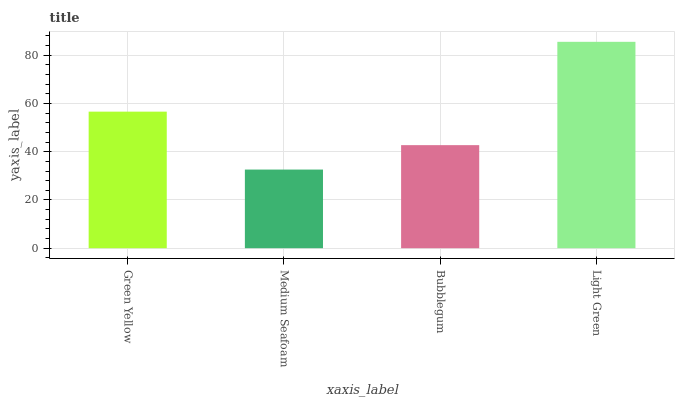Is Medium Seafoam the minimum?
Answer yes or no. Yes. Is Light Green the maximum?
Answer yes or no. Yes. Is Bubblegum the minimum?
Answer yes or no. No. Is Bubblegum the maximum?
Answer yes or no. No. Is Bubblegum greater than Medium Seafoam?
Answer yes or no. Yes. Is Medium Seafoam less than Bubblegum?
Answer yes or no. Yes. Is Medium Seafoam greater than Bubblegum?
Answer yes or no. No. Is Bubblegum less than Medium Seafoam?
Answer yes or no. No. Is Green Yellow the high median?
Answer yes or no. Yes. Is Bubblegum the low median?
Answer yes or no. Yes. Is Bubblegum the high median?
Answer yes or no. No. Is Light Green the low median?
Answer yes or no. No. 